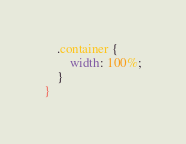<code> <loc_0><loc_0><loc_500><loc_500><_CSS_>    .container {
        width: 100%;
    }
}</code> 